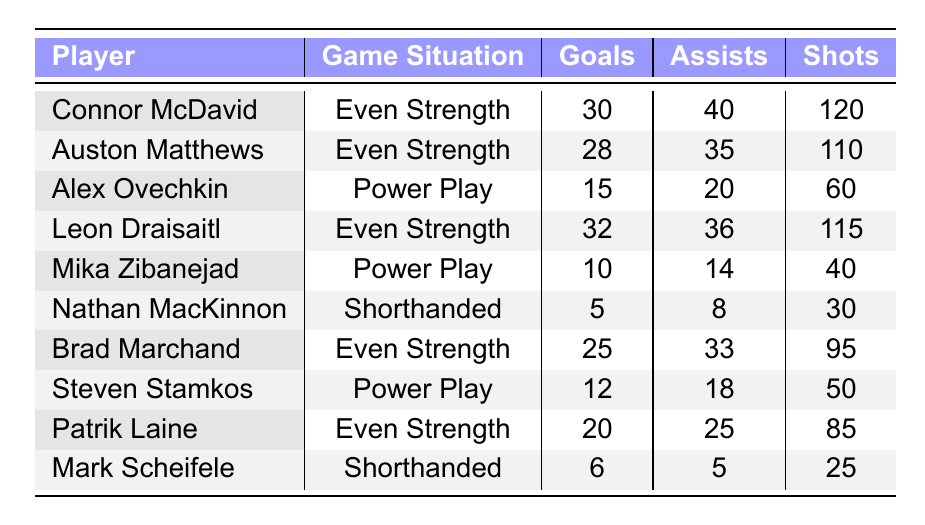What is the total number of goals scored by players during Even Strength situations? The players who scored during Even Strength are Connor McDavid (30), Auston Matthews (28), Leon Draisaitl (32), and Brad Marchand (25). Adding these values: 30 + 28 + 32 + 25 = 115.
Answer: 115 Which player had the most assists in Power Play situations? The players in Power Play situations are Alex Ovechkin (20) and Steven Stamkos (18). Alex Ovechkin has the most assists with 20.
Answer: Alex Ovechkin Is it true that Nathan MacKinnon scored more goals than Mark Scheifele? Nathan MacKinnon scored 5 goals while Mark Scheifele scored 6 goals. Since 5 is not greater than 6, the statement is false.
Answer: No What is the average number of shots taken by players during Even Strength situations? The players during Even Strength are Connor McDavid (120), Auston Matthews (110), Leon Draisaitl (115), and Brad Marchand (95). The total shots are 120 + 110 + 115 + 95 = 440. The average is 440 / 4 = 110.
Answer: 110 Who had the highest Time on Ice among the players listed? The Time on Ice for players is: Connor McDavid (18.5), Auston Matthews (17.2), Leon Draisaitl (19.0), Brad Marchand (17.8), Alex Ovechkin (6.5), Mika Zibanejad (5.0), Nathan MacKinnon (2.0), Steven Stamkos (5.8), Patrik Laine (16.0), and Mark Scheifele (2.5). The highest Time on Ice is 19.0 by Leon Draisaitl.
Answer: Leon Draisaitl How many players scored 20 goals or more? The players who scored 20 goals or more are Connor McDavid (30), Auston Matthews (28), Leon Draisaitl (32), Brad Marchand (25), and Patrik Laine (20). Counting these, there are 5 players.
Answer: 5 